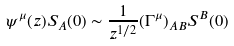<formula> <loc_0><loc_0><loc_500><loc_500>\psi ^ { \mu } ( z ) S _ { A } ( 0 ) \sim \frac { 1 } { z ^ { 1 / 2 } } ( \Gamma ^ { \mu } ) _ { A B } S ^ { B } ( 0 )</formula> 